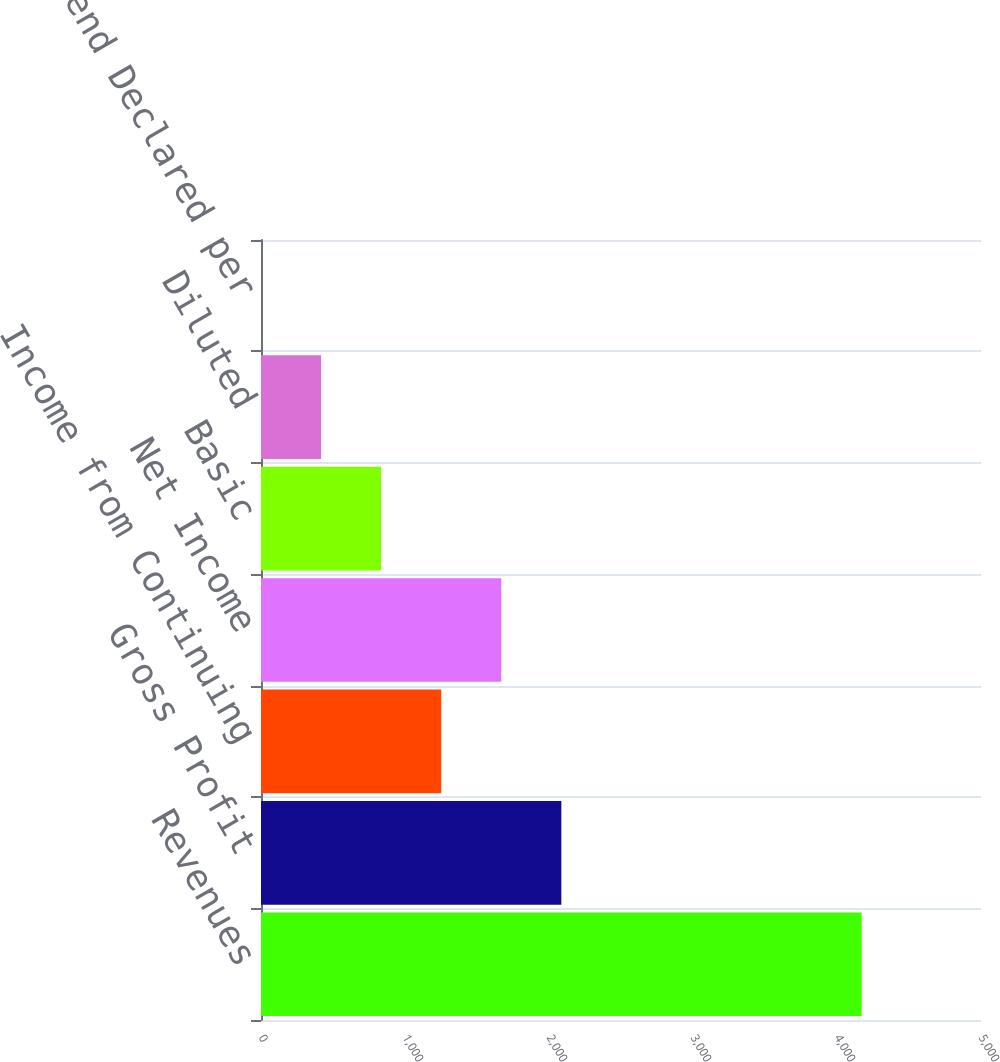Convert chart to OTSL. <chart><loc_0><loc_0><loc_500><loc_500><bar_chart><fcel>Revenues<fcel>Gross Profit<fcel>Income from Continuing<fcel>Net Income<fcel>Basic<fcel>Diluted<fcel>Cash Dividend Declared per<nl><fcel>4171.4<fcel>2085.76<fcel>1251.51<fcel>1668.63<fcel>834.39<fcel>417.27<fcel>0.15<nl></chart> 